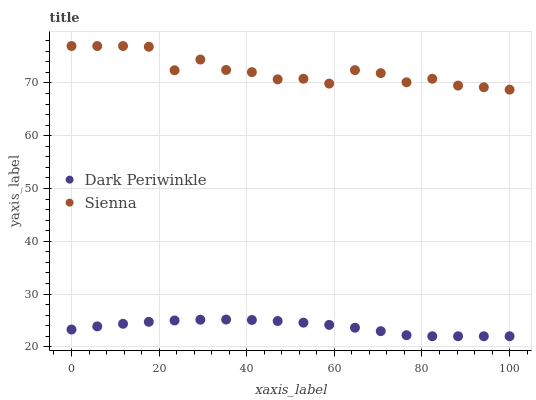Does Dark Periwinkle have the minimum area under the curve?
Answer yes or no. Yes. Does Sienna have the maximum area under the curve?
Answer yes or no. Yes. Does Dark Periwinkle have the maximum area under the curve?
Answer yes or no. No. Is Dark Periwinkle the smoothest?
Answer yes or no. Yes. Is Sienna the roughest?
Answer yes or no. Yes. Is Dark Periwinkle the roughest?
Answer yes or no. No. Does Dark Periwinkle have the lowest value?
Answer yes or no. Yes. Does Sienna have the highest value?
Answer yes or no. Yes. Does Dark Periwinkle have the highest value?
Answer yes or no. No. Is Dark Periwinkle less than Sienna?
Answer yes or no. Yes. Is Sienna greater than Dark Periwinkle?
Answer yes or no. Yes. Does Dark Periwinkle intersect Sienna?
Answer yes or no. No. 